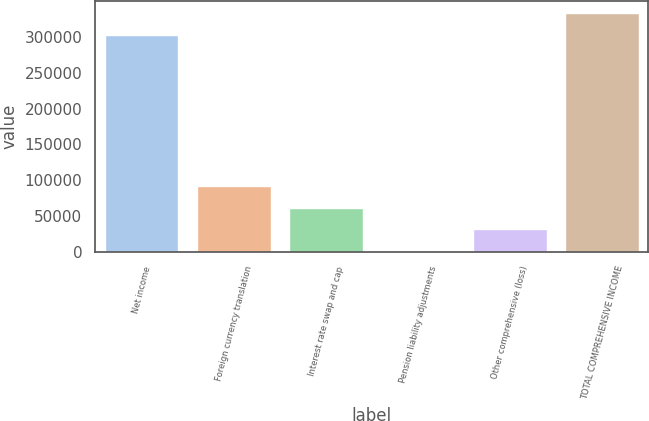<chart> <loc_0><loc_0><loc_500><loc_500><bar_chart><fcel>Net income<fcel>Foreign currency translation<fcel>Interest rate swap and cap<fcel>Pension liability adjustments<fcel>Other comprehensive (loss)<fcel>TOTAL COMPREHENSIVE INCOME<nl><fcel>302789<fcel>92000.7<fcel>61668.8<fcel>1005<fcel>31336.9<fcel>333121<nl></chart> 